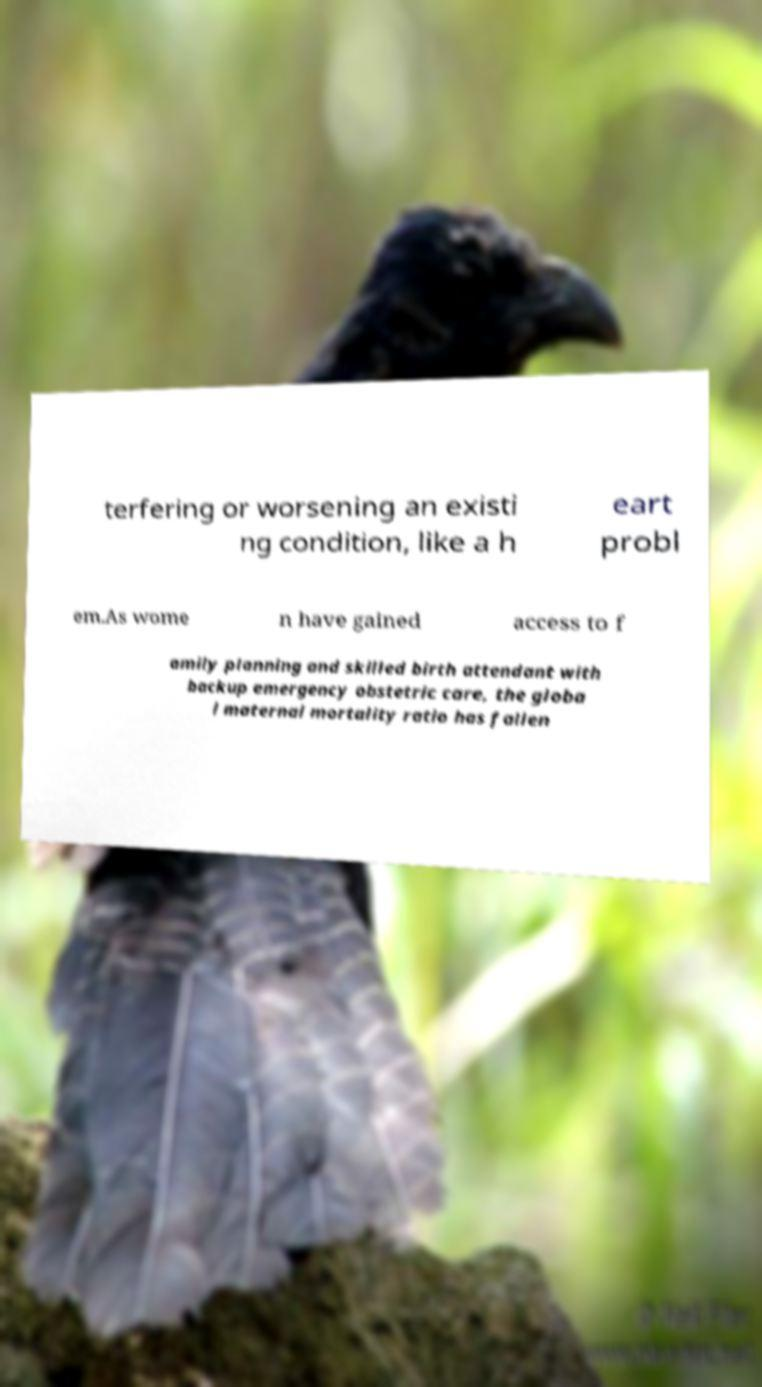There's text embedded in this image that I need extracted. Can you transcribe it verbatim? terfering or worsening an existi ng condition, like a h eart probl em.As wome n have gained access to f amily planning and skilled birth attendant with backup emergency obstetric care, the globa l maternal mortality ratio has fallen 